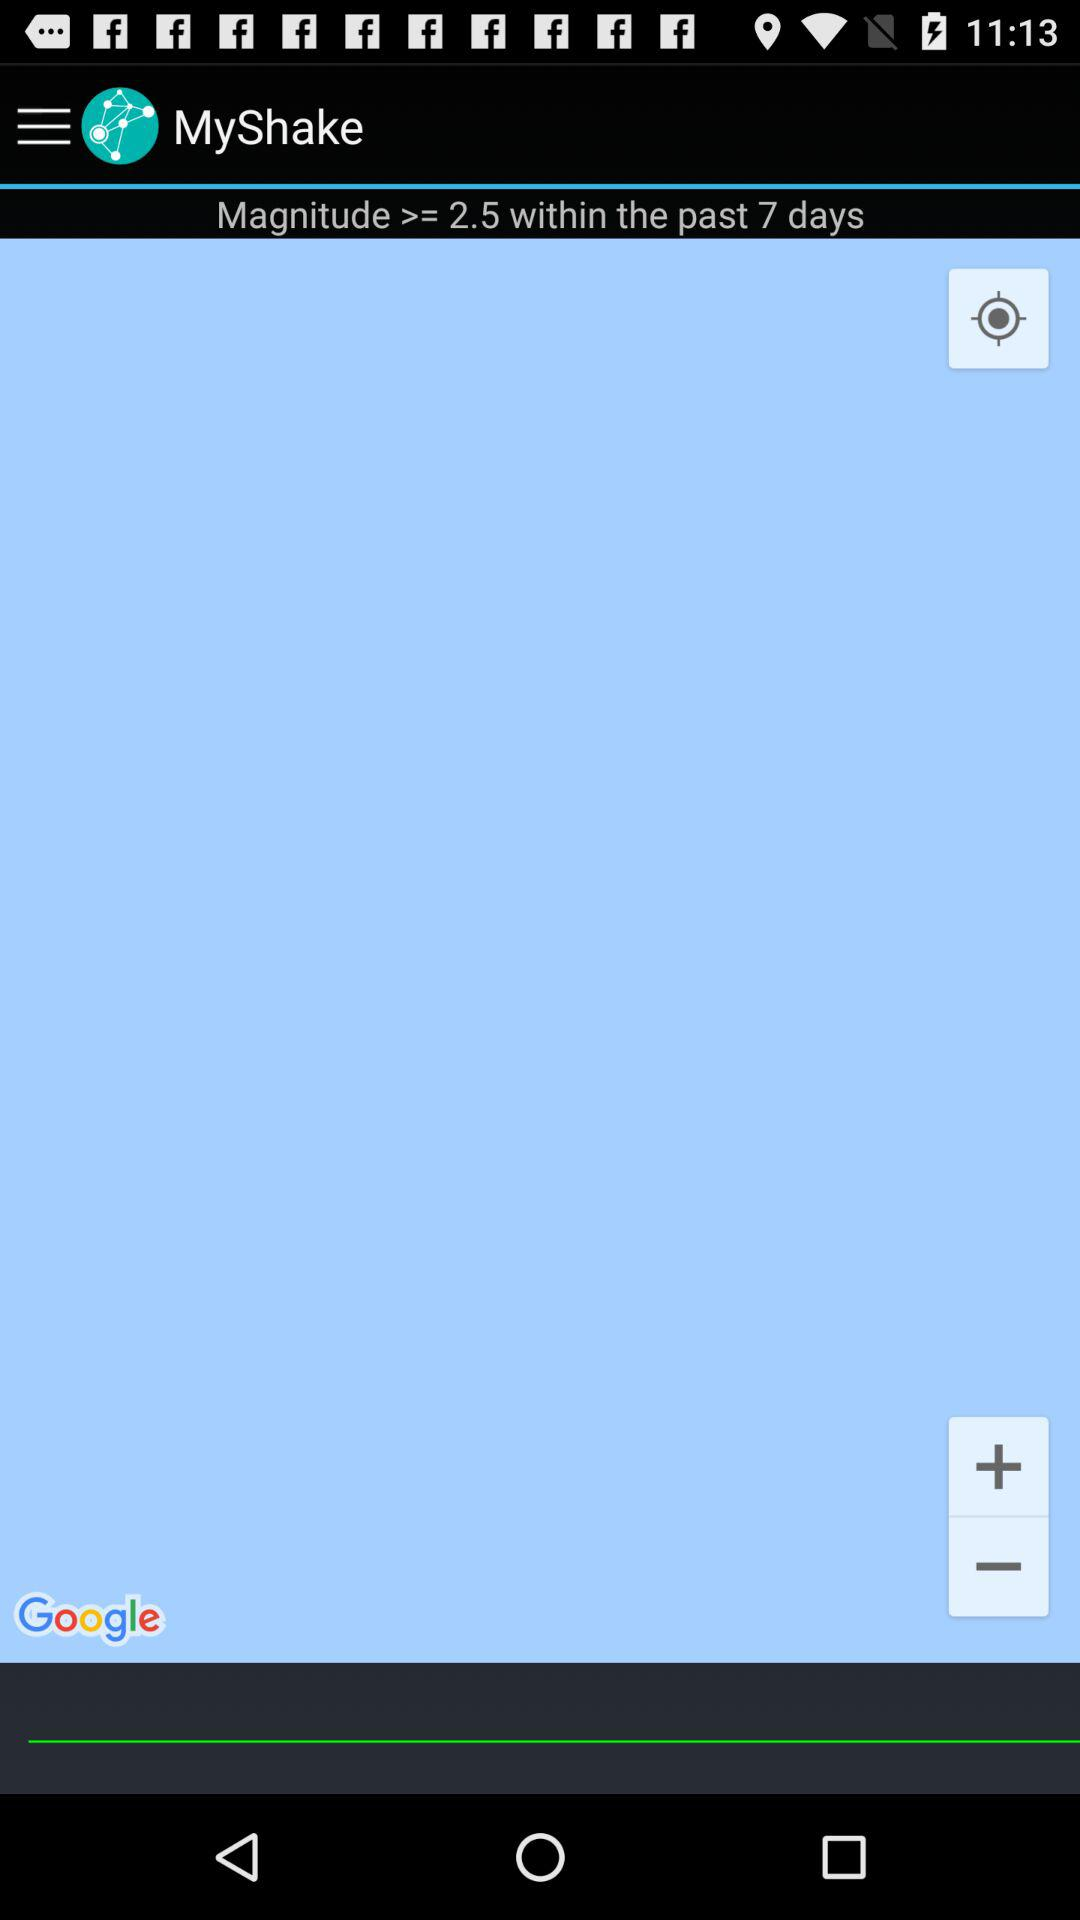What is the magnitude within the past 7 days? The magnitude within the past 7 days is greater and equal to 2.5. 